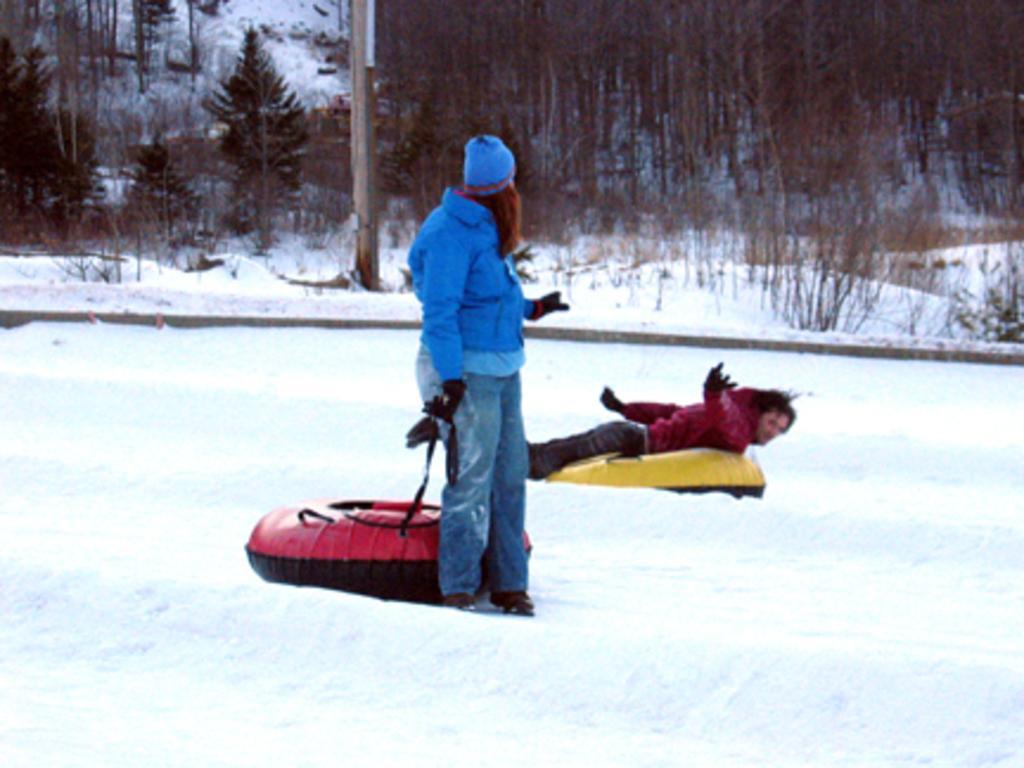How would you summarize this image in a sentence or two? In this image, we can see people wearing coats and gloves and one of them is holding a snow tube and the other is lying on the tube. In the background, there are trees and we can see a pole. At the bottom, there is snow. 